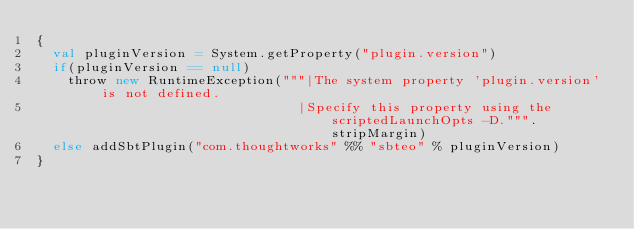<code> <loc_0><loc_0><loc_500><loc_500><_Scala_>{
  val pluginVersion = System.getProperty("plugin.version")
  if(pluginVersion == null)
    throw new RuntimeException("""|The system property 'plugin.version' is not defined.
                                 |Specify this property using the scriptedLaunchOpts -D.""".stripMargin)
  else addSbtPlugin("com.thoughtworks" %% "sbteo" % pluginVersion)
}
</code> 